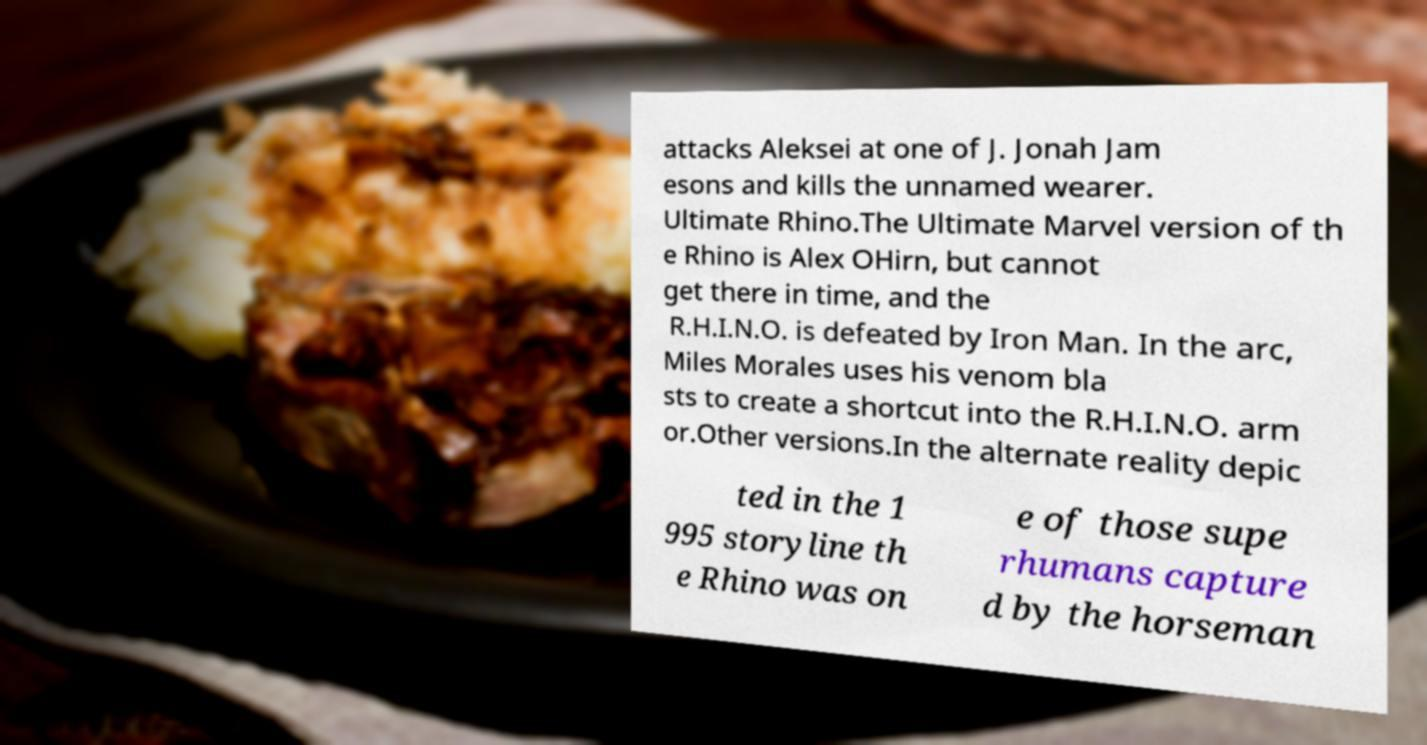I need the written content from this picture converted into text. Can you do that? attacks Aleksei at one of J. Jonah Jam esons and kills the unnamed wearer. Ultimate Rhino.The Ultimate Marvel version of th e Rhino is Alex OHirn, but cannot get there in time, and the R.H.I.N.O. is defeated by Iron Man. In the arc, Miles Morales uses his venom bla sts to create a shortcut into the R.H.I.N.O. arm or.Other versions.In the alternate reality depic ted in the 1 995 storyline th e Rhino was on e of those supe rhumans capture d by the horseman 